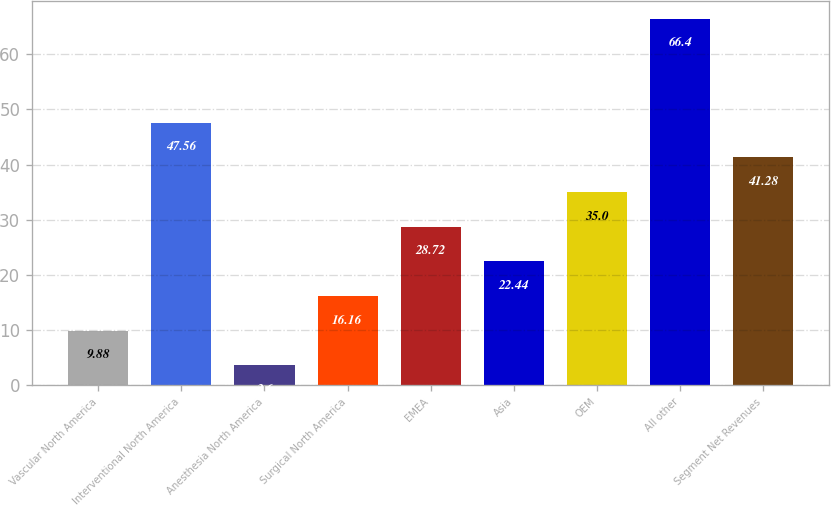Convert chart to OTSL. <chart><loc_0><loc_0><loc_500><loc_500><bar_chart><fcel>Vascular North America<fcel>Interventional North America<fcel>Anesthesia North America<fcel>Surgical North America<fcel>EMEA<fcel>Asia<fcel>OEM<fcel>All other<fcel>Segment Net Revenues<nl><fcel>9.88<fcel>47.56<fcel>3.6<fcel>16.16<fcel>28.72<fcel>22.44<fcel>35<fcel>66.4<fcel>41.28<nl></chart> 